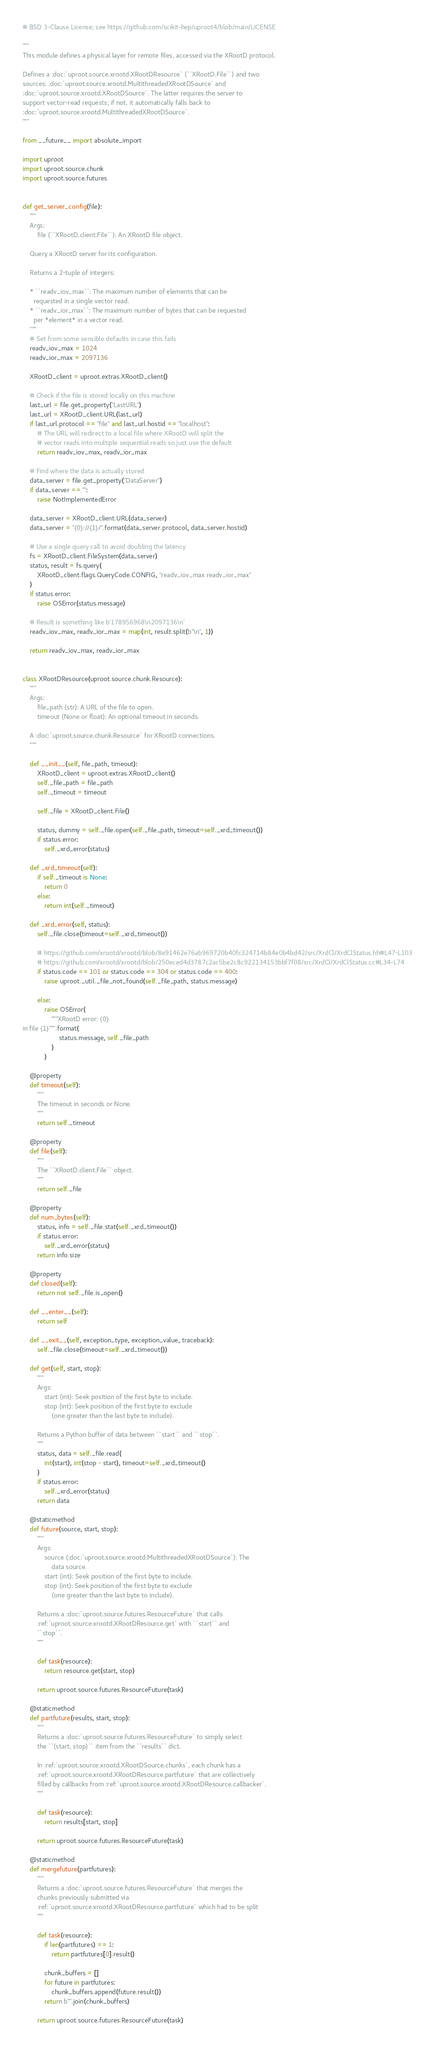<code> <loc_0><loc_0><loc_500><loc_500><_Python_># BSD 3-Clause License; see https://github.com/scikit-hep/uproot4/blob/main/LICENSE

"""
This module defines a physical layer for remote files, accessed via the XRootD protocol.

Defines a :doc:`uproot.source.xrootd.XRootDResource` (``XRootD.File``) and two
sources: :doc:`uproot.source.xrootd.MultithreadedXRootDSource` and
:doc:`uproot.source.xrootd.XRootDSource`. The latter requires the server to
support vector-read requests; if not, it automatically falls back to
:doc:`uproot.source.xrootd.MultithreadedXRootDSource`.
"""

from __future__ import absolute_import

import uproot
import uproot.source.chunk
import uproot.source.futures


def get_server_config(file):
    """
    Args:
        file (``XRootD.client.File``): An XRootD file object.

    Query a XRootD server for its configuration.

    Returns a 2-tuple of integers:

    * ``readv_iov_max``: The maximum number of elements that can be
      requested in a single vector read.
    * ``readv_ior_max``: The maximum number of bytes that can be requested
      per *element* in a vector read.
    """
    # Set from some sensible defaults in case this fails
    readv_iov_max = 1024
    readv_ior_max = 2097136

    XRootD_client = uproot.extras.XRootD_client()

    # Check if the file is stored locally on this machine
    last_url = file.get_property("LastURL")
    last_url = XRootD_client.URL(last_url)
    if last_url.protocol == "file" and last_url.hostid == "localhost":
        # The URL will redirect to a local file where XRootD will split the
        # vector reads into multiple sequential reads so just use the default
        return readv_iov_max, readv_ior_max

    # Find where the data is actually stored
    data_server = file.get_property("DataServer")
    if data_server == "":
        raise NotImplementedError

    data_server = XRootD_client.URL(data_server)
    data_server = "{0}://{1}/".format(data_server.protocol, data_server.hostid)

    # Use a single query call to avoid doubling the latency
    fs = XRootD_client.FileSystem(data_server)
    status, result = fs.query(
        XRootD_client.flags.QueryCode.CONFIG, "readv_iov_max readv_ior_max"
    )
    if status.error:
        raise OSError(status.message)

    # Result is something like b'178956968\n2097136\n'
    readv_iov_max, readv_ior_max = map(int, result.split(b"\n", 1))

    return readv_iov_max, readv_ior_max


class XRootDResource(uproot.source.chunk.Resource):
    """
    Args:
        file_path (str): A URL of the file to open.
        timeout (None or float): An optional timeout in seconds.

    A :doc:`uproot.source.chunk.Resource` for XRootD connections.
    """

    def __init__(self, file_path, timeout):
        XRootD_client = uproot.extras.XRootD_client()
        self._file_path = file_path
        self._timeout = timeout

        self._file = XRootD_client.File()

        status, dummy = self._file.open(self._file_path, timeout=self._xrd_timeout())
        if status.error:
            self._xrd_error(status)

    def _xrd_timeout(self):
        if self._timeout is None:
            return 0
        else:
            return int(self._timeout)

    def _xrd_error(self, status):
        self._file.close(timeout=self._xrd_timeout())

        # https://github.com/xrootd/xrootd/blob/8e91462e76ab969720b40fc324714b84e0b4bd42/src/XrdCl/XrdClStatus.hh#L47-L103
        # https://github.com/xrootd/xrootd/blob/250eced4d3787c2ac5be2c8c922134153bbf7f08/src/XrdCl/XrdClStatus.cc#L34-L74
        if status.code == 101 or status.code == 304 or status.code == 400:
            raise uproot._util._file_not_found(self._file_path, status.message)

        else:
            raise OSError(
                """XRootD error: {0}
in file {1}""".format(
                    status.message, self._file_path
                )
            )

    @property
    def timeout(self):
        """
        The timeout in seconds or None.
        """
        return self._timeout

    @property
    def file(self):
        """
        The ``XRootD.client.File`` object.
        """
        return self._file

    @property
    def num_bytes(self):
        status, info = self._file.stat(self._xrd_timeout())
        if status.error:
            self._xrd_error(status)
        return info.size

    @property
    def closed(self):
        return not self._file.is_open()

    def __enter__(self):
        return self

    def __exit__(self, exception_type, exception_value, traceback):
        self._file.close(timeout=self._xrd_timeout())

    def get(self, start, stop):
        """
        Args:
            start (int): Seek position of the first byte to include.
            stop (int): Seek position of the first byte to exclude
                (one greater than the last byte to include).

        Returns a Python buffer of data between ``start`` and ``stop``.
        """
        status, data = self._file.read(
            int(start), int(stop - start), timeout=self._xrd_timeout()
        )
        if status.error:
            self._xrd_error(status)
        return data

    @staticmethod
    def future(source, start, stop):
        """
        Args:
            source (:doc:`uproot.source.xrootd.MultithreadedXRootDSource`): The
                data source.
            start (int): Seek position of the first byte to include.
            stop (int): Seek position of the first byte to exclude
                (one greater than the last byte to include).

        Returns a :doc:`uproot.source.futures.ResourceFuture` that calls
        :ref:`uproot.source.xrootd.XRootDResource.get` with ``start`` and
        ``stop``.
        """

        def task(resource):
            return resource.get(start, stop)

        return uproot.source.futures.ResourceFuture(task)

    @staticmethod
    def partfuture(results, start, stop):
        """
        Returns a :doc:`uproot.source.futures.ResourceFuture` to simply select
        the ``(start, stop)`` item from the ``results`` dict.

        In :ref:`uproot.source.xrootd.XRootDSource.chunks`, each chunk has a
        :ref:`uproot.source.xrootd.XRootDResource.partfuture` that are collectively
        filled by callbacks from :ref:`uproot.source.xrootd.XRootDResource.callbacker`.
        """

        def task(resource):
            return results[start, stop]

        return uproot.source.futures.ResourceFuture(task)

    @staticmethod
    def mergefuture(partfutures):
        """
        Returns a :doc:`uproot.source.futures.ResourceFuture` that merges the
        chunks previously submitted via
        :ref:`uproot.source.xrootd.XRootDResource.partfuture` which had to be split
        """

        def task(resource):
            if len(partfutures) == 1:
                return partfutures[0].result()

            chunk_buffers = []
            for future in partfutures:
                chunk_buffers.append(future.result())
            return b"".join(chunk_buffers)

        return uproot.source.futures.ResourceFuture(task)
</code> 